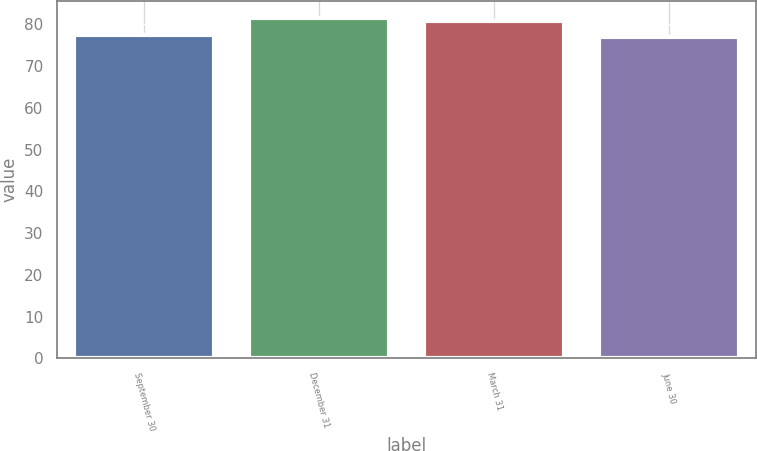<chart> <loc_0><loc_0><loc_500><loc_500><bar_chart><fcel>September 30<fcel>December 31<fcel>March 31<fcel>June 30<nl><fcel>77.55<fcel>81.57<fcel>80.82<fcel>77.1<nl></chart> 